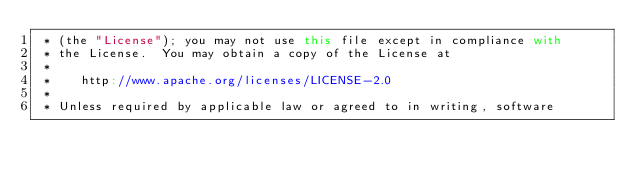<code> <loc_0><loc_0><loc_500><loc_500><_Scala_> * (the "License"); you may not use this file except in compliance with
 * the License.  You may obtain a copy of the License at
 *
 *    http://www.apache.org/licenses/LICENSE-2.0
 *
 * Unless required by applicable law or agreed to in writing, software</code> 